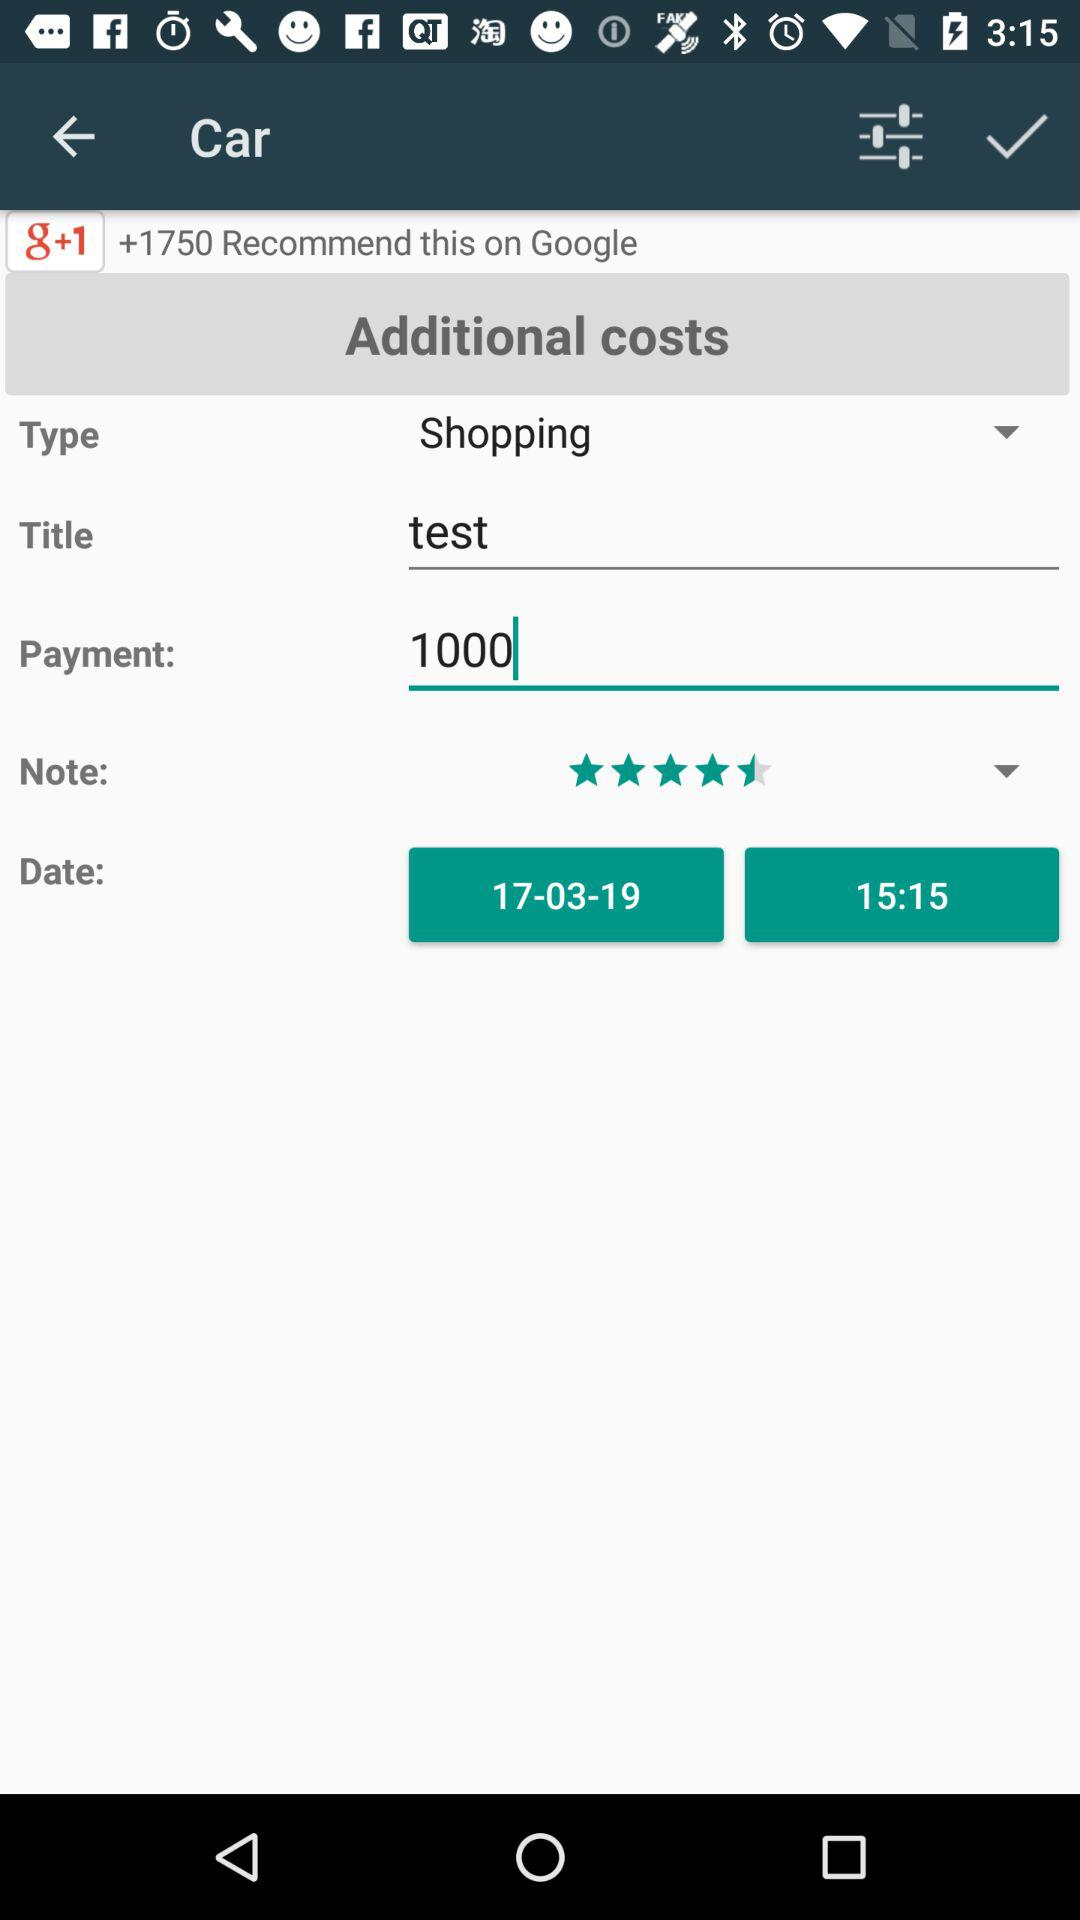What is the date of this trip?
Answer the question using a single word or phrase. 17-03-19 